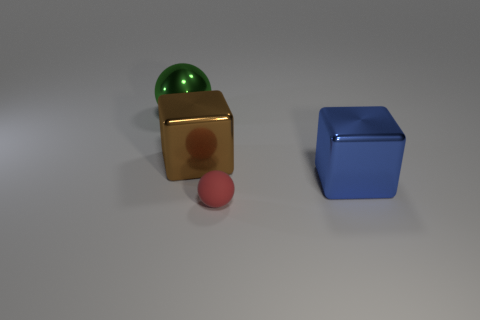There is a thing that is left of the brown thing; what is its shape?
Your response must be concise. Sphere. How many other things are there of the same size as the brown metal block?
Your answer should be compact. 2. Does the big brown metal thing that is to the left of the tiny matte object have the same shape as the object that is to the right of the tiny matte ball?
Give a very brief answer. Yes. There is a small red ball; what number of big green things are on the left side of it?
Provide a succinct answer. 1. The big metallic cube that is on the left side of the matte object is what color?
Your answer should be very brief. Brown. There is a tiny object that is the same shape as the large green shiny object; what color is it?
Provide a succinct answer. Red. Is there anything else that is the same color as the tiny matte sphere?
Provide a succinct answer. No. Is the number of tiny green balls greater than the number of large brown blocks?
Ensure brevity in your answer.  No. Are the large brown cube and the green object made of the same material?
Your answer should be very brief. Yes. How many other gray spheres have the same material as the large ball?
Give a very brief answer. 0. 